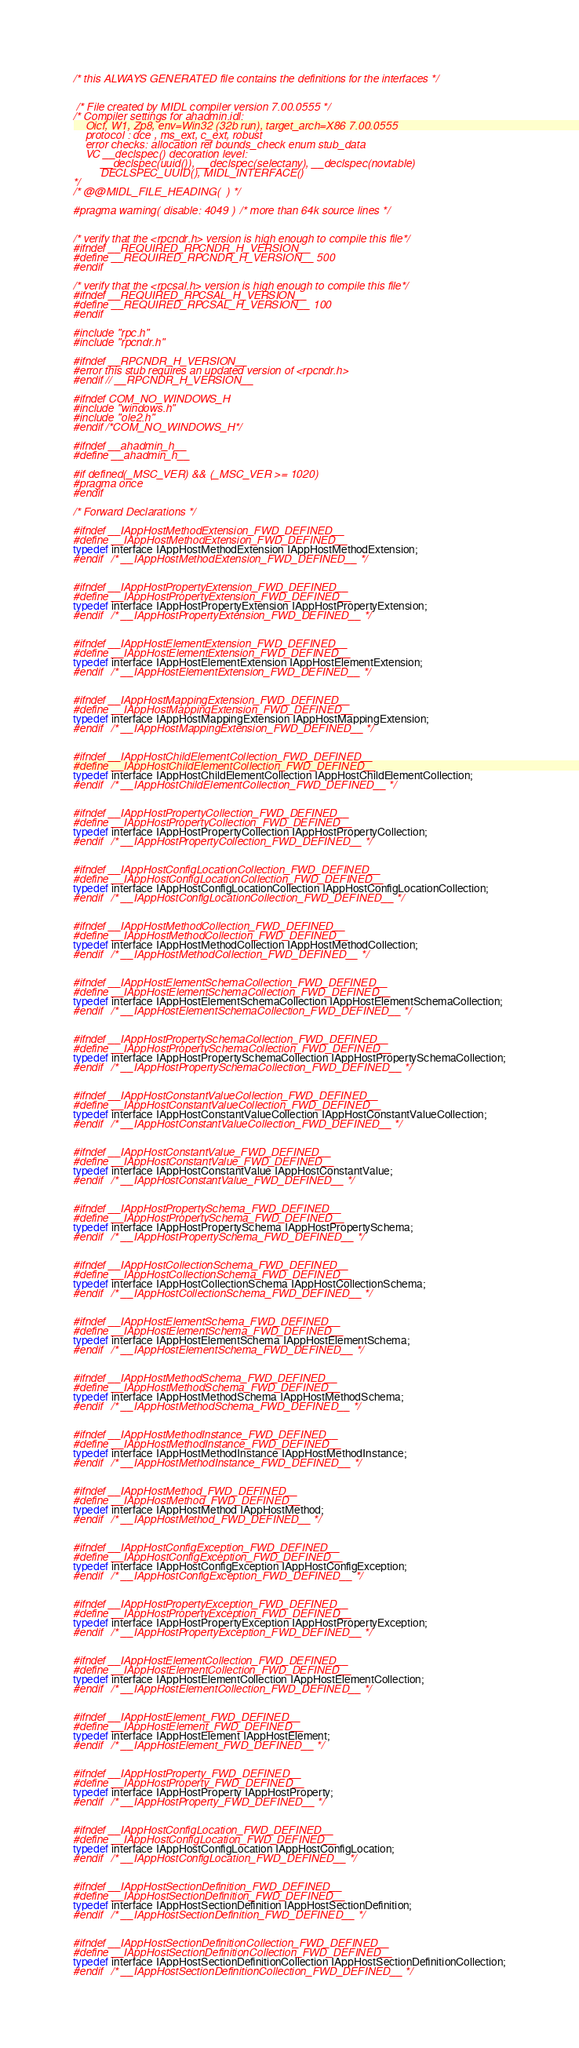<code> <loc_0><loc_0><loc_500><loc_500><_C_>

/* this ALWAYS GENERATED file contains the definitions for the interfaces */


 /* File created by MIDL compiler version 7.00.0555 */
/* Compiler settings for ahadmin.idl:
    Oicf, W1, Zp8, env=Win32 (32b run), target_arch=X86 7.00.0555 
    protocol : dce , ms_ext, c_ext, robust
    error checks: allocation ref bounds_check enum stub_data 
    VC __declspec() decoration level: 
         __declspec(uuid()), __declspec(selectany), __declspec(novtable)
         DECLSPEC_UUID(), MIDL_INTERFACE()
*/
/* @@MIDL_FILE_HEADING(  ) */

#pragma warning( disable: 4049 )  /* more than 64k source lines */


/* verify that the <rpcndr.h> version is high enough to compile this file*/
#ifndef __REQUIRED_RPCNDR_H_VERSION__
#define __REQUIRED_RPCNDR_H_VERSION__ 500
#endif

/* verify that the <rpcsal.h> version is high enough to compile this file*/
#ifndef __REQUIRED_RPCSAL_H_VERSION__
#define __REQUIRED_RPCSAL_H_VERSION__ 100
#endif

#include "rpc.h"
#include "rpcndr.h"

#ifndef __RPCNDR_H_VERSION__
#error this stub requires an updated version of <rpcndr.h>
#endif // __RPCNDR_H_VERSION__

#ifndef COM_NO_WINDOWS_H
#include "windows.h"
#include "ole2.h"
#endif /*COM_NO_WINDOWS_H*/

#ifndef __ahadmin_h__
#define __ahadmin_h__

#if defined(_MSC_VER) && (_MSC_VER >= 1020)
#pragma once
#endif

/* Forward Declarations */ 

#ifndef __IAppHostMethodExtension_FWD_DEFINED__
#define __IAppHostMethodExtension_FWD_DEFINED__
typedef interface IAppHostMethodExtension IAppHostMethodExtension;
#endif 	/* __IAppHostMethodExtension_FWD_DEFINED__ */


#ifndef __IAppHostPropertyExtension_FWD_DEFINED__
#define __IAppHostPropertyExtension_FWD_DEFINED__
typedef interface IAppHostPropertyExtension IAppHostPropertyExtension;
#endif 	/* __IAppHostPropertyExtension_FWD_DEFINED__ */


#ifndef __IAppHostElementExtension_FWD_DEFINED__
#define __IAppHostElementExtension_FWD_DEFINED__
typedef interface IAppHostElementExtension IAppHostElementExtension;
#endif 	/* __IAppHostElementExtension_FWD_DEFINED__ */


#ifndef __IAppHostMappingExtension_FWD_DEFINED__
#define __IAppHostMappingExtension_FWD_DEFINED__
typedef interface IAppHostMappingExtension IAppHostMappingExtension;
#endif 	/* __IAppHostMappingExtension_FWD_DEFINED__ */


#ifndef __IAppHostChildElementCollection_FWD_DEFINED__
#define __IAppHostChildElementCollection_FWD_DEFINED__
typedef interface IAppHostChildElementCollection IAppHostChildElementCollection;
#endif 	/* __IAppHostChildElementCollection_FWD_DEFINED__ */


#ifndef __IAppHostPropertyCollection_FWD_DEFINED__
#define __IAppHostPropertyCollection_FWD_DEFINED__
typedef interface IAppHostPropertyCollection IAppHostPropertyCollection;
#endif 	/* __IAppHostPropertyCollection_FWD_DEFINED__ */


#ifndef __IAppHostConfigLocationCollection_FWD_DEFINED__
#define __IAppHostConfigLocationCollection_FWD_DEFINED__
typedef interface IAppHostConfigLocationCollection IAppHostConfigLocationCollection;
#endif 	/* __IAppHostConfigLocationCollection_FWD_DEFINED__ */


#ifndef __IAppHostMethodCollection_FWD_DEFINED__
#define __IAppHostMethodCollection_FWD_DEFINED__
typedef interface IAppHostMethodCollection IAppHostMethodCollection;
#endif 	/* __IAppHostMethodCollection_FWD_DEFINED__ */


#ifndef __IAppHostElementSchemaCollection_FWD_DEFINED__
#define __IAppHostElementSchemaCollection_FWD_DEFINED__
typedef interface IAppHostElementSchemaCollection IAppHostElementSchemaCollection;
#endif 	/* __IAppHostElementSchemaCollection_FWD_DEFINED__ */


#ifndef __IAppHostPropertySchemaCollection_FWD_DEFINED__
#define __IAppHostPropertySchemaCollection_FWD_DEFINED__
typedef interface IAppHostPropertySchemaCollection IAppHostPropertySchemaCollection;
#endif 	/* __IAppHostPropertySchemaCollection_FWD_DEFINED__ */


#ifndef __IAppHostConstantValueCollection_FWD_DEFINED__
#define __IAppHostConstantValueCollection_FWD_DEFINED__
typedef interface IAppHostConstantValueCollection IAppHostConstantValueCollection;
#endif 	/* __IAppHostConstantValueCollection_FWD_DEFINED__ */


#ifndef __IAppHostConstantValue_FWD_DEFINED__
#define __IAppHostConstantValue_FWD_DEFINED__
typedef interface IAppHostConstantValue IAppHostConstantValue;
#endif 	/* __IAppHostConstantValue_FWD_DEFINED__ */


#ifndef __IAppHostPropertySchema_FWD_DEFINED__
#define __IAppHostPropertySchema_FWD_DEFINED__
typedef interface IAppHostPropertySchema IAppHostPropertySchema;
#endif 	/* __IAppHostPropertySchema_FWD_DEFINED__ */


#ifndef __IAppHostCollectionSchema_FWD_DEFINED__
#define __IAppHostCollectionSchema_FWD_DEFINED__
typedef interface IAppHostCollectionSchema IAppHostCollectionSchema;
#endif 	/* __IAppHostCollectionSchema_FWD_DEFINED__ */


#ifndef __IAppHostElementSchema_FWD_DEFINED__
#define __IAppHostElementSchema_FWD_DEFINED__
typedef interface IAppHostElementSchema IAppHostElementSchema;
#endif 	/* __IAppHostElementSchema_FWD_DEFINED__ */


#ifndef __IAppHostMethodSchema_FWD_DEFINED__
#define __IAppHostMethodSchema_FWD_DEFINED__
typedef interface IAppHostMethodSchema IAppHostMethodSchema;
#endif 	/* __IAppHostMethodSchema_FWD_DEFINED__ */


#ifndef __IAppHostMethodInstance_FWD_DEFINED__
#define __IAppHostMethodInstance_FWD_DEFINED__
typedef interface IAppHostMethodInstance IAppHostMethodInstance;
#endif 	/* __IAppHostMethodInstance_FWD_DEFINED__ */


#ifndef __IAppHostMethod_FWD_DEFINED__
#define __IAppHostMethod_FWD_DEFINED__
typedef interface IAppHostMethod IAppHostMethod;
#endif 	/* __IAppHostMethod_FWD_DEFINED__ */


#ifndef __IAppHostConfigException_FWD_DEFINED__
#define __IAppHostConfigException_FWD_DEFINED__
typedef interface IAppHostConfigException IAppHostConfigException;
#endif 	/* __IAppHostConfigException_FWD_DEFINED__ */


#ifndef __IAppHostPropertyException_FWD_DEFINED__
#define __IAppHostPropertyException_FWD_DEFINED__
typedef interface IAppHostPropertyException IAppHostPropertyException;
#endif 	/* __IAppHostPropertyException_FWD_DEFINED__ */


#ifndef __IAppHostElementCollection_FWD_DEFINED__
#define __IAppHostElementCollection_FWD_DEFINED__
typedef interface IAppHostElementCollection IAppHostElementCollection;
#endif 	/* __IAppHostElementCollection_FWD_DEFINED__ */


#ifndef __IAppHostElement_FWD_DEFINED__
#define __IAppHostElement_FWD_DEFINED__
typedef interface IAppHostElement IAppHostElement;
#endif 	/* __IAppHostElement_FWD_DEFINED__ */


#ifndef __IAppHostProperty_FWD_DEFINED__
#define __IAppHostProperty_FWD_DEFINED__
typedef interface IAppHostProperty IAppHostProperty;
#endif 	/* __IAppHostProperty_FWD_DEFINED__ */


#ifndef __IAppHostConfigLocation_FWD_DEFINED__
#define __IAppHostConfigLocation_FWD_DEFINED__
typedef interface IAppHostConfigLocation IAppHostConfigLocation;
#endif 	/* __IAppHostConfigLocation_FWD_DEFINED__ */


#ifndef __IAppHostSectionDefinition_FWD_DEFINED__
#define __IAppHostSectionDefinition_FWD_DEFINED__
typedef interface IAppHostSectionDefinition IAppHostSectionDefinition;
#endif 	/* __IAppHostSectionDefinition_FWD_DEFINED__ */


#ifndef __IAppHostSectionDefinitionCollection_FWD_DEFINED__
#define __IAppHostSectionDefinitionCollection_FWD_DEFINED__
typedef interface IAppHostSectionDefinitionCollection IAppHostSectionDefinitionCollection;
#endif 	/* __IAppHostSectionDefinitionCollection_FWD_DEFINED__ */

</code> 